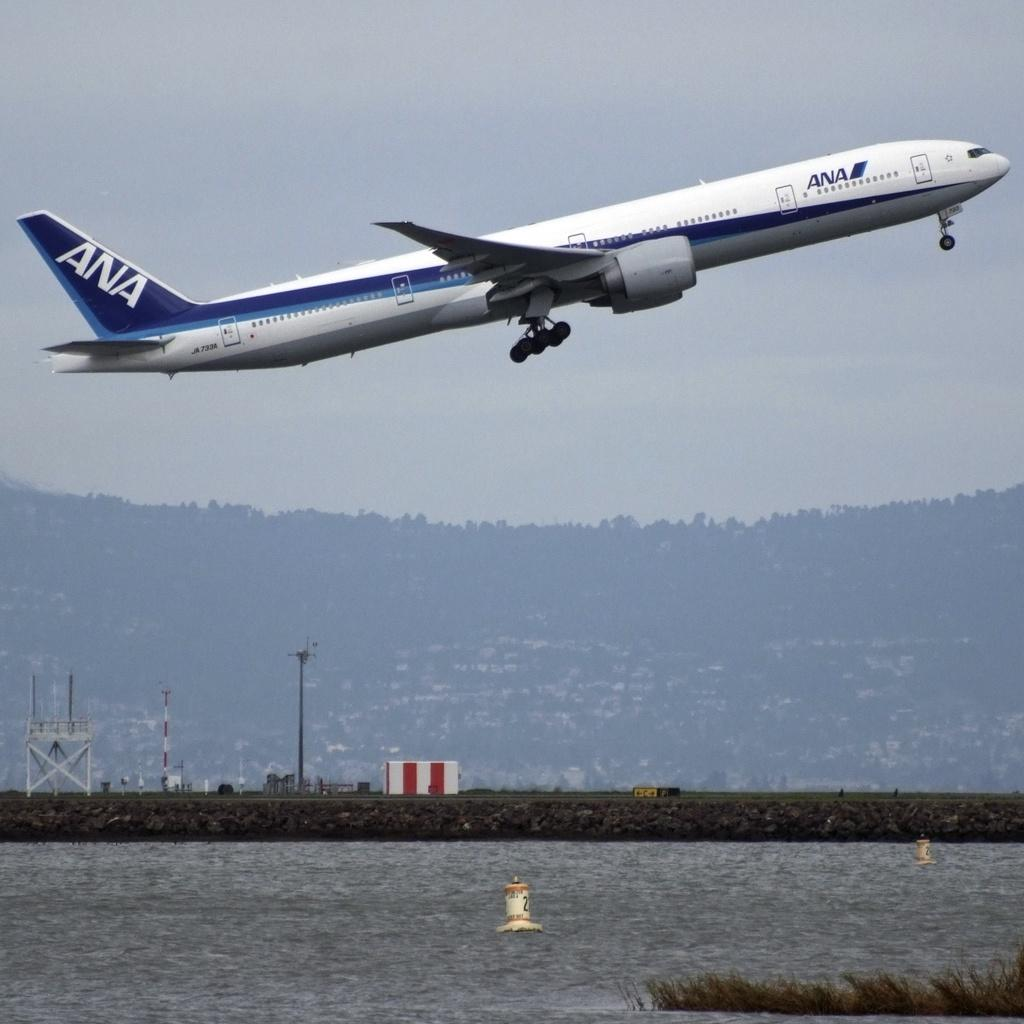<image>
Create a compact narrative representing the image presented. An ANA airplane ascends over a body of water. 